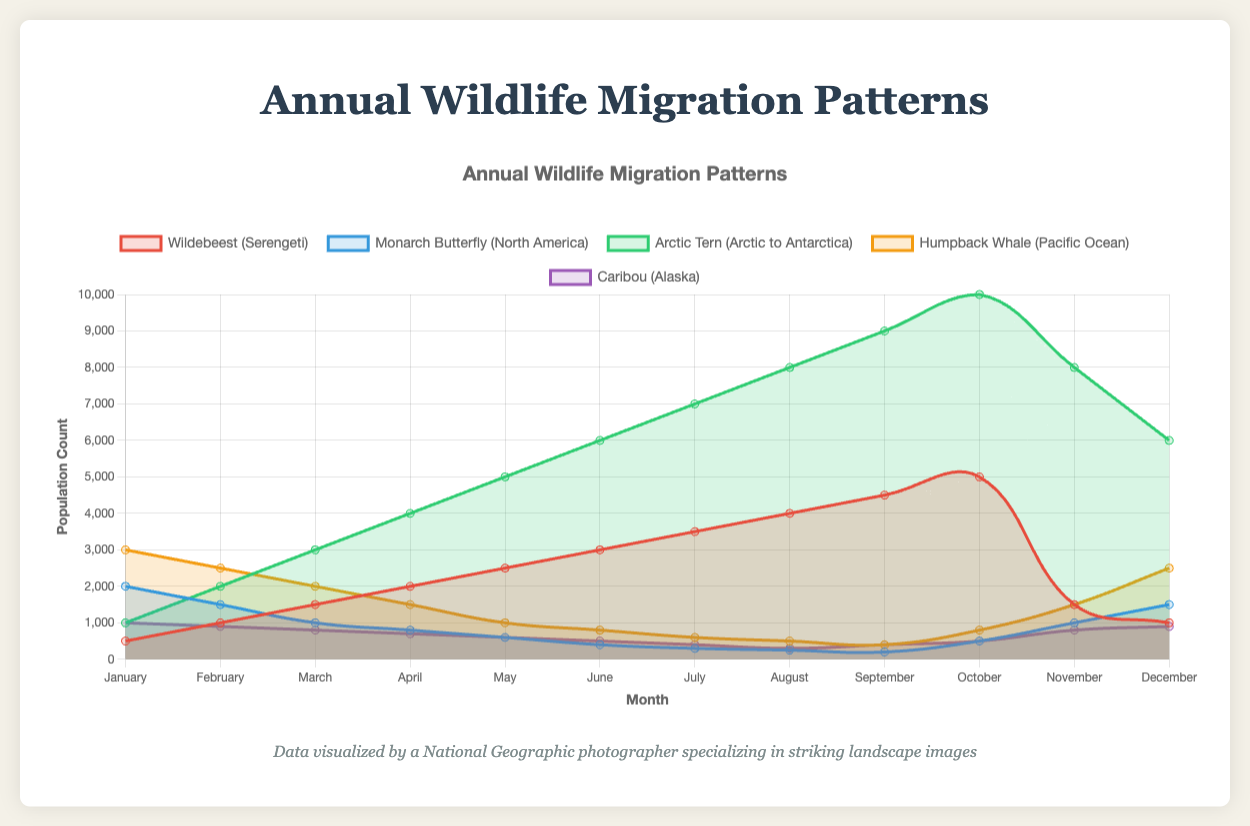What is the peak population count for the Wildebeests and in which month does it occur? The peak population count for the Wildebeests can be found by identifying the highest point on the Wildebeest line graph. The highest point is at 5000, which occurs in October.
Answer: 5000 in October What is the difference between the highest and lowest population counts for the Monarch Butterfly? The highest population count for the Monarch Butterfly is 2000 in January, and the lowest is 200 in September. The difference is calculated as 2000 - 200 = 1800.
Answer: 1800 Between the Arctic Tern and Humpback Whale, which species shows higher population counts in September? In September, the Arctic Tern has a population count of 9000, while the Humpback Whale has a population count of 400. Comparing these values, Arctic Tern has the higher count.
Answer: Arctic Tern How does the population trend of Caribou change throughout the year? The population of Caribou generally decreases from January to August, reaching a low point, and then it increases from September to December. This can be visually observed from the slope of the line descending from January to August and then ascending from September onward.
Answer: Decreases first, then increases Which month shows the maximum count difference between Wildebeest and Caribou? To find the maximum count difference, we calculate the differences for each month: January (500 - 1000 = -500), February (1000 - 900 = 100), March (1500 - 800 = 700), April (2000 - 700 = 1300), May (2500 - 600 = 1900), June (3000 - 500 = 2500), July (3500 - 400 = 3100), August (4000 - 300 = 3700), September (4500 - 400 = 4100), October (5000 - 500 = 4500), November (1500 - 800 = 700), December (1000 - 900 = 100). The maximum difference is in October with 4500.
Answer: October What trends do you observe in the population counts of Humpback Whales from January to December, and can you relate this to their migration patterns? The population of Humpback Whales starts high in January at 3000, decreases to 500 in August, and then rises again to 2500 in December, indicating a cyclical migration pattern where they are more concentrated in specific months. The decrease could represent migration away from a key area and the increase a return.
Answer: High in January and December, low in August Which species has the largest overall variation in their population throughout the year? To determine the largest overall variation, we compare the difference between the highest and lowest values for each species:
- Wildebeest: 5000 - 500 = 4500
- Monarch Butterfly: 2000 - 200 = 1800
- Arctic Tern: 10000 - 1000 = 9000
- Humpback Whale: 3000 - 400 = 2600
- Caribou: 1000 - 300 = 700
The Arctic Tern shows the largest variation of 9000.
Answer: Arctic Tern During which month do all species except the Arctic Tern show a decrease in population count? To identify the month where all species except the Arctic Tern show a decrease, we need to examine changes month over month. Comparing:
- Wildebeest: In November to December drops from 1500 to 1000.
- Monarch Butterfly: In June to July drops from 400 to 300.
- Humpback Whale: In February to March drops from 2500 to 2000.
- Caribou: In February to March drops from 900 to 800.
- Arctic Tern is excluded.
All the other species decrease in these specified months. We can designate March as a representative month showing the declines for most.
Answer: March 